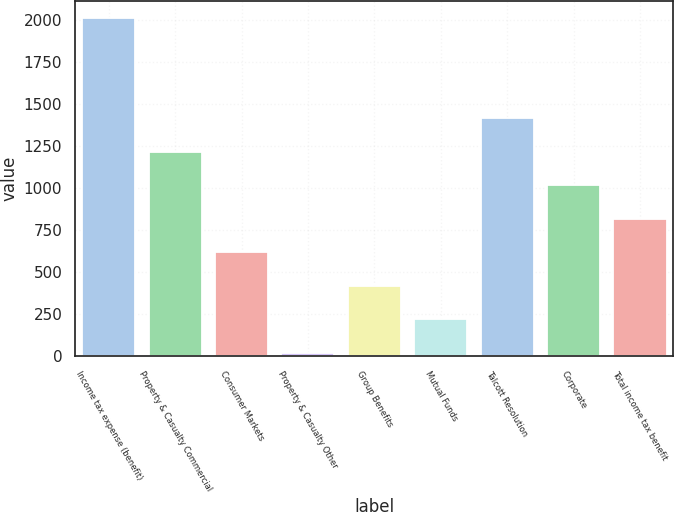Convert chart. <chart><loc_0><loc_0><loc_500><loc_500><bar_chart><fcel>Income tax expense (benefit)<fcel>Property & Casualty Commercial<fcel>Consumer Markets<fcel>Property & Casualty Other<fcel>Group Benefits<fcel>Mutual Funds<fcel>Talcott Resolution<fcel>Corporate<fcel>Total income tax benefit<nl><fcel>2013<fcel>1215.8<fcel>617.9<fcel>20<fcel>418.6<fcel>219.3<fcel>1415.1<fcel>1016.5<fcel>817.2<nl></chart> 